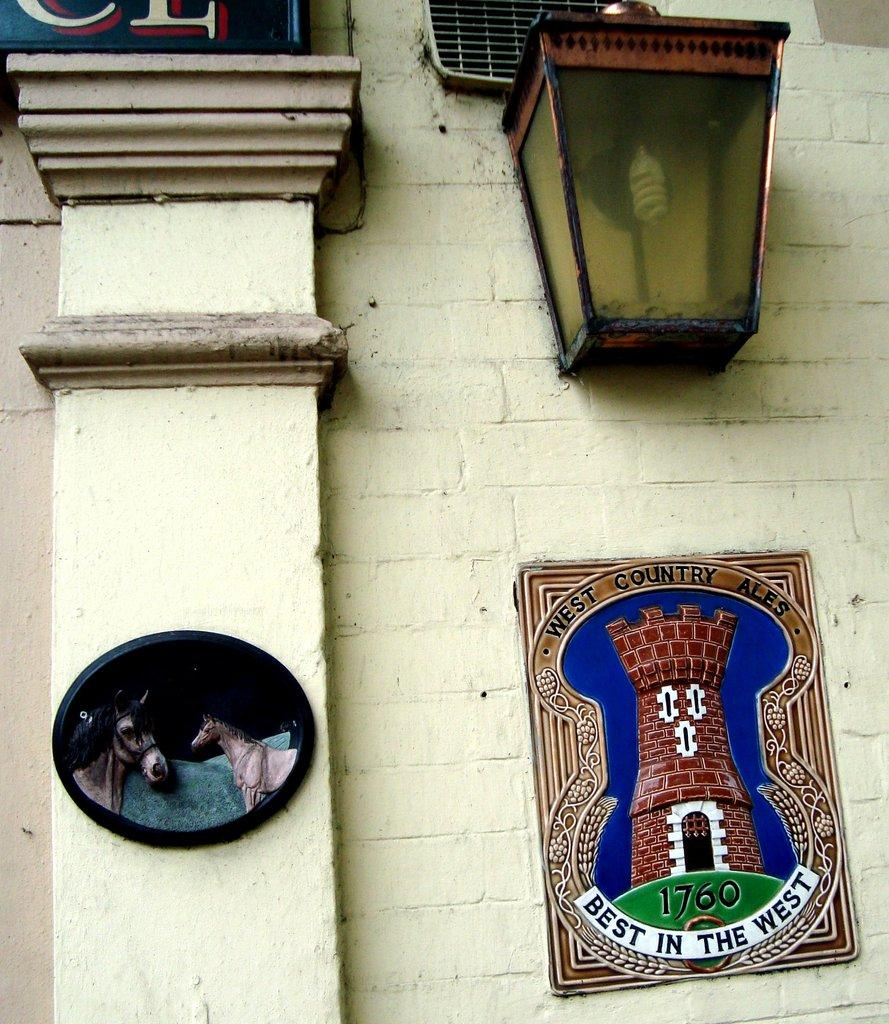What is hanging on the wall in the image? There is a photo on the wall in the image. What is positioned above the photo on the wall? There is a lamp above the photo on the wall. What can be seen on the left side of the image? There is a pillar on the left side of the image. What is depicted in the photo on the pillar? There is a photo of a horse on the pillar. What type of apple is being used as a paperweight on the table in the image? There is no apple or table present in the image; it only features a photo on the wall, a lamp above it, a pillar, and a photo of a horse on the pillar. What invention is being showcased in the room in the image? There is no room or invention mentioned in the image; it only contains a photo on the wall, a lamp above it, a pillar, and a photo of a horse on the pillar. 